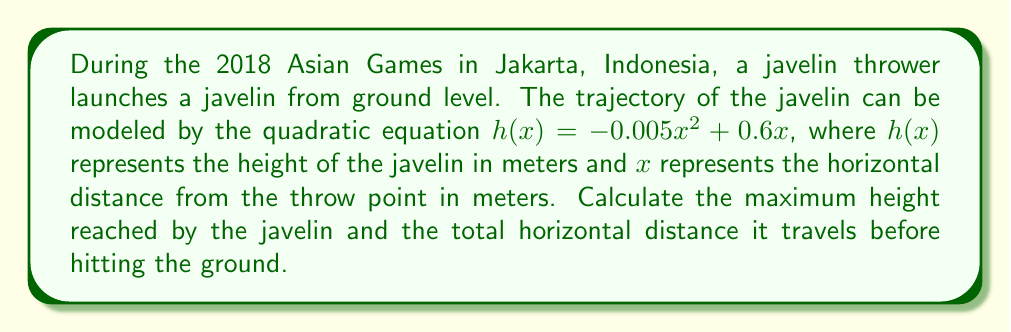Can you solve this math problem? To solve this problem, we'll follow these steps:

1. Find the vertex of the parabola to determine the maximum height:
   The general form of a quadratic equation is $f(x) = ax^2 + bx + c$
   In this case, $a = -0.005$, $b = 0.6$, and $c = 0$

   The x-coordinate of the vertex is given by $x = -\frac{b}{2a}$:
   $$x = -\frac{0.6}{2(-0.005)} = 60$$

   The maximum height (y-coordinate of the vertex) is:
   $$h(60) = -0.005(60)^2 + 0.6(60) = -18 + 36 = 18$$

2. Find the horizontal distance traveled by solving $h(x) = 0$:
   $$0 = -0.005x^2 + 0.6x$$
   $$0.005x^2 = 0.6x$$
   $$0.005x(x - 120) = 0$$

   The solutions are $x = 0$ and $x = 120$. Since $x = 0$ is the starting point, the javelin lands at $x = 120$ meters.

Therefore, the maximum height reached is 18 meters, and the total horizontal distance traveled is 120 meters.
Answer: Maximum height: 18 meters
Total horizontal distance: 120 meters 